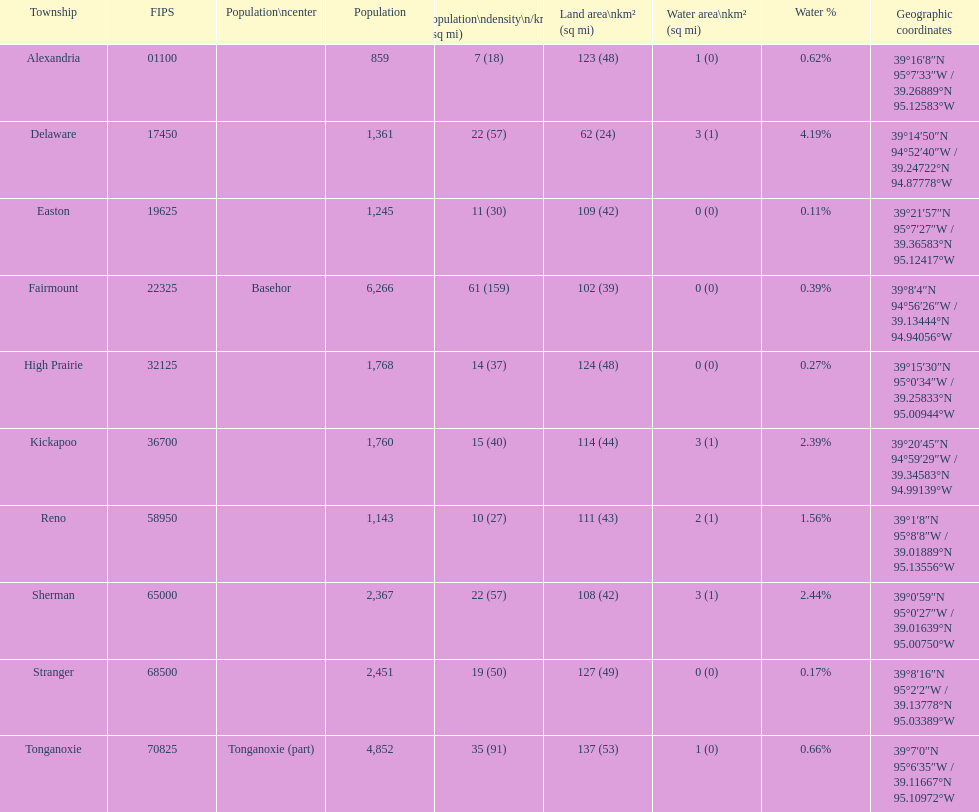Which county has a larger population: alexandria or delaware? Lower. 